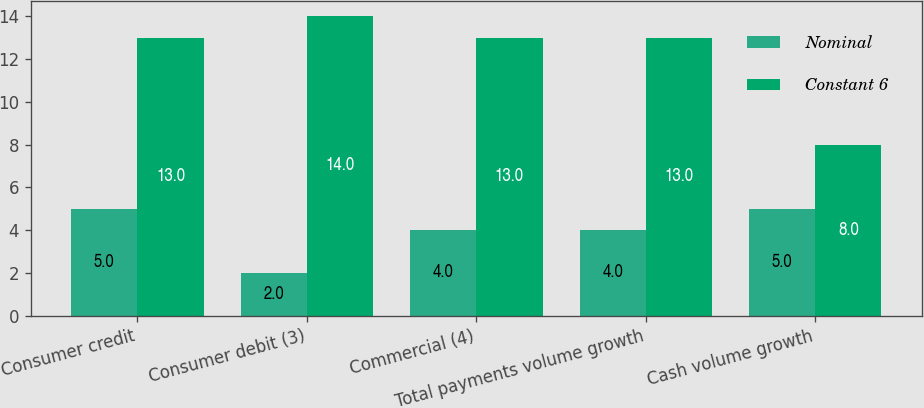Convert chart. <chart><loc_0><loc_0><loc_500><loc_500><stacked_bar_chart><ecel><fcel>Consumer credit<fcel>Consumer debit (3)<fcel>Commercial (4)<fcel>Total payments volume growth<fcel>Cash volume growth<nl><fcel>Nominal<fcel>5<fcel>2<fcel>4<fcel>4<fcel>5<nl><fcel>Constant 6<fcel>13<fcel>14<fcel>13<fcel>13<fcel>8<nl></chart> 